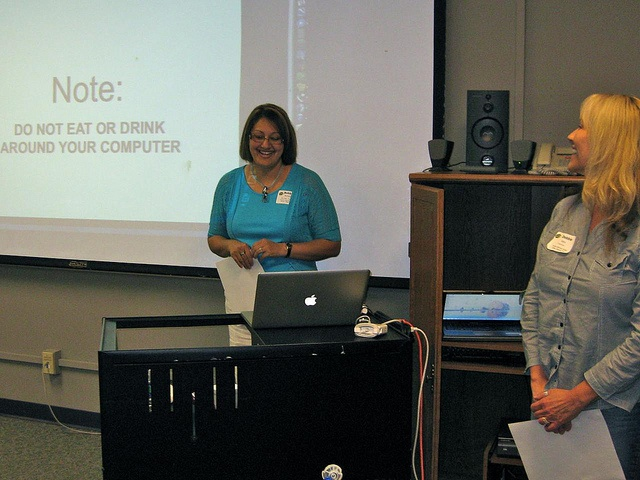Describe the objects in this image and their specific colors. I can see tv in lightgray, darkgray, and lightblue tones, people in lightgray, gray, olive, and black tones, people in lightgray, teal, black, and maroon tones, laptop in lightgray, black, gray, and darkgray tones, and laptop in lightgray, black, darkgray, and gray tones in this image. 